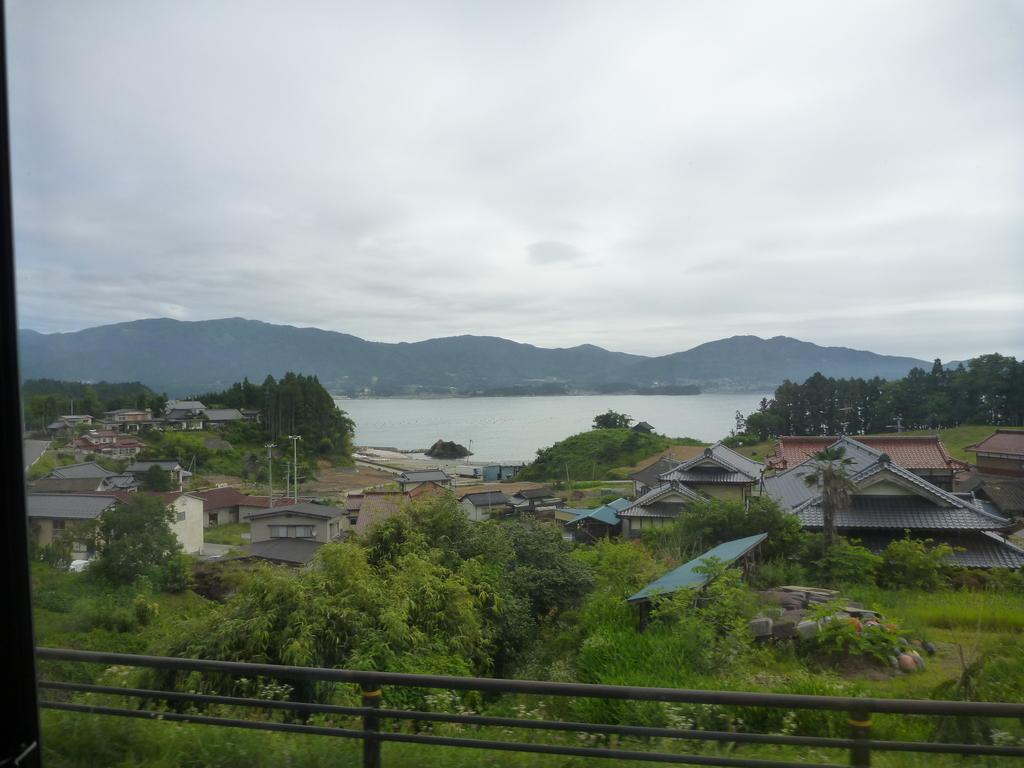What type of natural vegetation can be seen in the image? There are trees in the image. What type of structures are present in the image? There are houses in the image. What can be seen in the distance in the background of the image? There are mountains and water visible in the background of the image. How would you describe the weather in the image? The sky is cloudy in the background of the image, suggesting a potentially overcast or cloudy day. How many minutes does it take for the tent to be set up in the image? There is no tent present in the image, so it is not possible to determine how long it would take to set up. 